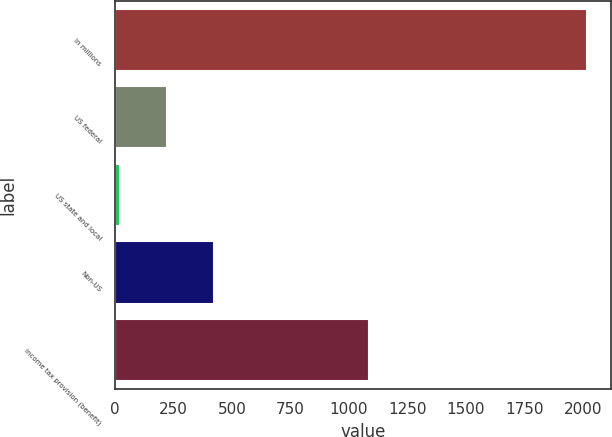Convert chart. <chart><loc_0><loc_0><loc_500><loc_500><bar_chart><fcel>In millions<fcel>US federal<fcel>US state and local<fcel>Non-US<fcel>Income tax provision (benefit)<nl><fcel>2017<fcel>222.4<fcel>23<fcel>421.8<fcel>1085<nl></chart> 